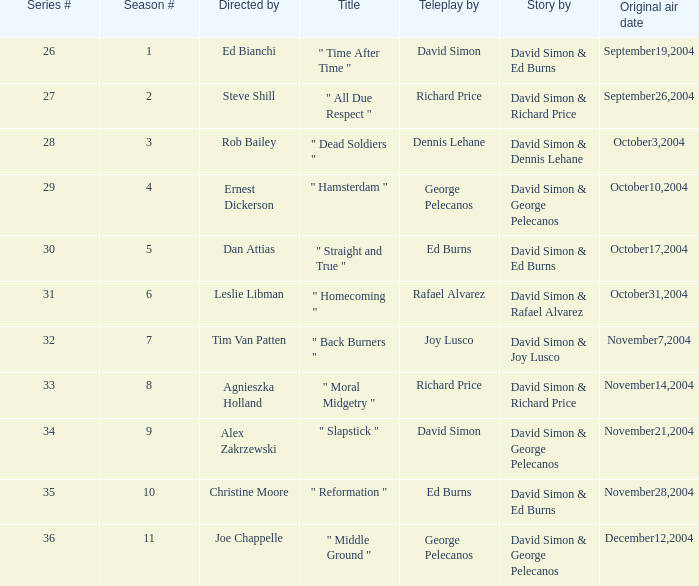Who is the teleplay by when the director is Rob Bailey? Dennis Lehane. 